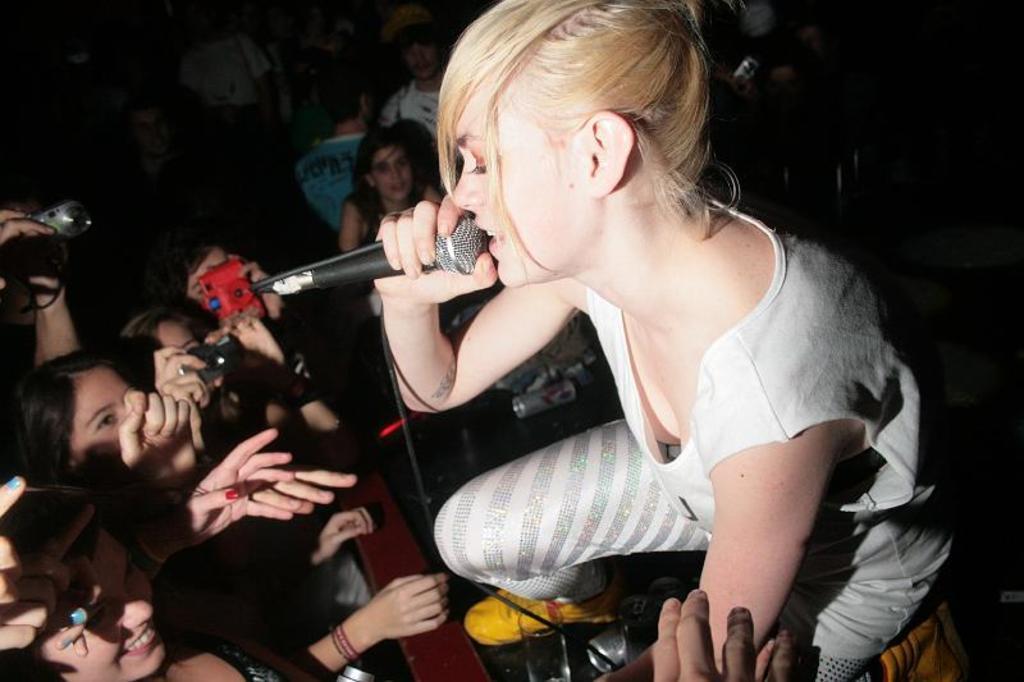Please provide a concise description of this image. In this picture there is a woman singing on the dais. She wore a white dress, yellow shoes and is holding a microphone in her hand. On the dais there is glass and a drink can. There are spectators. At the left corner there are two people holding a camera in their hand. 